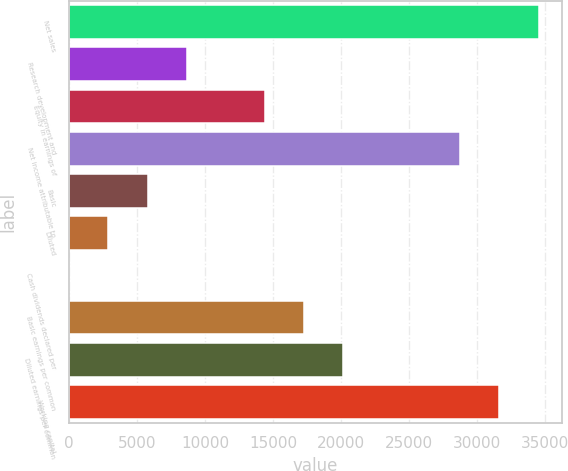Convert chart. <chart><loc_0><loc_0><loc_500><loc_500><bar_chart><fcel>Net sales<fcel>Research development and<fcel>Equity in earnings of<fcel>Net income attributable to<fcel>Basic<fcel>Diluted<fcel>Cash dividends declared per<fcel>Basic earnings per common<fcel>Diluted earnings per common<fcel>Working capital<nl><fcel>34560<fcel>8640.17<fcel>14400.1<fcel>28800<fcel>5760.19<fcel>2880.21<fcel>0.23<fcel>17280.1<fcel>20160.1<fcel>31680<nl></chart> 